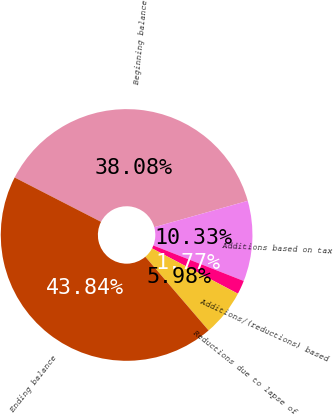Convert chart to OTSL. <chart><loc_0><loc_0><loc_500><loc_500><pie_chart><fcel>Beginning balance<fcel>Additions based on tax<fcel>Additions/(reductions) based<fcel>Reductions due to lapse of<fcel>Ending balance<nl><fcel>38.08%<fcel>10.33%<fcel>1.77%<fcel>5.98%<fcel>43.84%<nl></chart> 